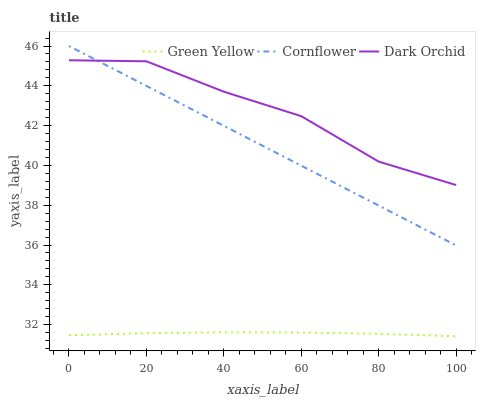Does Dark Orchid have the minimum area under the curve?
Answer yes or no. No. Does Green Yellow have the maximum area under the curve?
Answer yes or no. No. Is Green Yellow the smoothest?
Answer yes or no. No. Is Green Yellow the roughest?
Answer yes or no. No. Does Dark Orchid have the lowest value?
Answer yes or no. No. Does Dark Orchid have the highest value?
Answer yes or no. No. Is Green Yellow less than Cornflower?
Answer yes or no. Yes. Is Dark Orchid greater than Green Yellow?
Answer yes or no. Yes. Does Green Yellow intersect Cornflower?
Answer yes or no. No. 